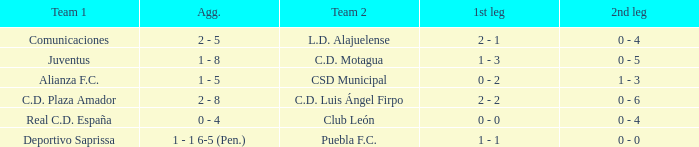What is the 1st leg where Team 1 is C.D. Plaza Amador? 2 - 2. 